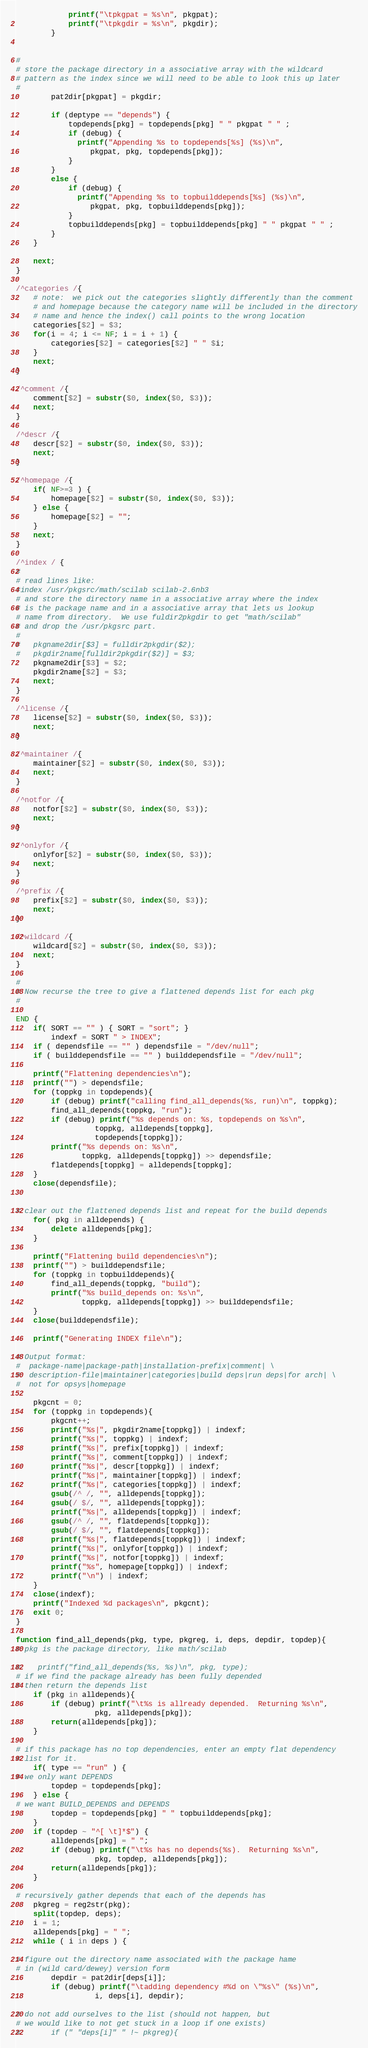<code> <loc_0><loc_0><loc_500><loc_500><_Awk_>			printf("\tpkgpat = %s\n", pkgpat);
			printf("\tpkgdir = %s\n", pkgdir);
		}


#
# store the package directory in a associative array with the wildcard
# pattern as the index since we will need to be able to look this up later
#
		pat2dir[pkgpat] = pkgdir;

		if (deptype == "depends") {
			topdepends[pkg] = topdepends[pkg] " " pkgpat " " ;
			if (debug) {
			  printf("Appending %s to topdepends[%s] (%s)\n",
				 pkgpat, pkg, topdepends[pkg]);
			}
		}
		else {
			if (debug) {
			  printf("Appending %s to topbuilddepends[%s] (%s)\n",
				 pkgpat, pkg, topbuilddepends[pkg]);
			}
			topbuilddepends[pkg] = topbuilddepends[pkg] " " pkgpat " " ;
		}
	}

	next;
}

/^categories /{
	# note:  we pick out the categories slightly differently than the comment
	# and homepage because the category name will be included in the directory
	# name and hence the index() call points to the wrong location
	categories[$2] = $3;
	for(i = 4; i <= NF; i = i + 1) {
		categories[$2] = categories[$2] " " $i;
	}
	next;
}

/^comment /{
	comment[$2] = substr($0, index($0, $3));
	next;
}

/^descr /{
	descr[$2] = substr($0, index($0, $3));
	next;
}

/^homepage /{
	if( NF>=3 ) {
		homepage[$2] = substr($0, index($0, $3));
	} else {
		homepage[$2] = "";
	}
	next;
}

/^index / {
#
# read lines like:
#index /usr/pkgsrc/math/scilab scilab-2.6nb3
# and store the directory name in a associative array where the index
# is the package name and in a associative array that lets us lookup
# name from directory.  We use fuldir2pkgdir to get "math/scilab"
# and drop the /usr/pkgsrc part.
#
#	pkgname2dir[$3] = fulldir2pkgdir($2);
#	pkgdir2name[fulldir2pkgdir($2)] = $3;
	pkgname2dir[$3] = $2;
	pkgdir2name[$2] = $3;
	next;
}

/^license /{
	license[$2] = substr($0, index($0, $3));
	next;
}

/^maintainer /{
	maintainer[$2] = substr($0, index($0, $3));
	next;
}

/^notfor /{
	notfor[$2] = substr($0, index($0, $3));
	next;
}

/^onlyfor /{
	onlyfor[$2] = substr($0, index($0, $3));
	next;
}

/^prefix /{
	prefix[$2] = substr($0, index($0, $3));
	next;
}

/^wildcard /{
	wildcard[$2] = substr($0, index($0, $3));
	next;
}

#
# Now recurse the tree to give a flattened depends list for each pkg
#

END {
	if( SORT == "" ) { SORT = "sort"; }
        indexf = SORT " > INDEX";
	if ( dependsfile == "" ) dependsfile = "/dev/null";
	if ( builddependsfile == "" ) builddependsfile = "/dev/null";

	printf("Flattening dependencies\n");
	printf("") > dependsfile;
	for (toppkg in topdepends){
		if (debug) printf("calling find_all_depends(%s, run)\n", toppkg);
		find_all_depends(toppkg, "run");
		if (debug) printf("%s depends on: %s, topdepends on %s\n",
				  toppkg, alldepends[toppkg],
				  topdepends[toppkg]);
		printf("%s depends on: %s\n",
		       toppkg, alldepends[toppkg]) >> dependsfile;
		flatdepends[toppkg] = alldepends[toppkg];
	}
	close(dependsfile);


# clear out the flattened depends list and repeat for the build depends
	for( pkg in alldepends) {
		delete alldepends[pkg];
	}

	printf("Flattening build dependencies\n");
	printf("") > builddependsfile;
	for (toppkg in topbuilddepends){
		find_all_depends(toppkg, "build");
		printf("%s build_depends on: %s\n",
		       toppkg, alldepends[toppkg]) >> builddependsfile;
	}
	close(builddependsfile);

	printf("Generating INDEX file\n");

# Output format:
#  package-name|package-path|installation-prefix|comment| \
#  description-file|maintainer|categories|build deps|run deps|for arch| \
#  not for opsys|homepage

	pkgcnt = 0;
	for (toppkg in topdepends){
		pkgcnt++;
		printf("%s|", pkgdir2name[toppkg]) | indexf;
		printf("%s|", toppkg) | indexf;
		printf("%s|", prefix[toppkg]) | indexf;
		printf("%s|", comment[toppkg]) | indexf;
		printf("%s|", descr[toppkg]) | indexf;
		printf("%s|", maintainer[toppkg]) | indexf;
		printf("%s|", categories[toppkg]) | indexf;
		gsub(/^ /, "", alldepends[toppkg]);
		gsub(/ $/, "", alldepends[toppkg]);
		printf("%s|", alldepends[toppkg]) | indexf;
		gsub(/^ /, "", flatdepends[toppkg]);
		gsub(/ $/, "", flatdepends[toppkg]);
		printf("%s|", flatdepends[toppkg]) | indexf;
		printf("%s|", onlyfor[toppkg]) | indexf;
		printf("%s|", notfor[toppkg]) | indexf;
		printf("%s", homepage[toppkg]) | indexf;
		printf("\n") | indexf;
	}
	close(indexf);
	printf("Indexed %d packages\n", pkgcnt);
	exit 0;
}

function find_all_depends(pkg, type, pkgreg, i, deps, depdir, topdep){
# pkg is the package directory, like math/scilab

#    printf("find_all_depends(%s, %s)\n", pkg, type);
# if we find the package already has been fully depended
# then return the depends list
	if (pkg in alldepends){
		if (debug) printf("\t%s is allready depended.  Returning %s\n",
				  pkg, alldepends[pkg]);
		return(alldepends[pkg]);
	}

# if this package has no top dependencies, enter an empty flat dependency
# list for it.
	if( type == "run" ) {
# we only want DEPENDS
		topdep = topdepends[pkg];
	} else {
# we want BUILD_DEPENDS and DEPENDS
		topdep = topdepends[pkg] " " topbuilddepends[pkg];
	}
	if (topdep ~ "^[ \t]*$") {
		alldepends[pkg] = " ";
		if (debug) printf("\t%s has no depends(%s).  Returning %s\n",
				  pkg, topdep, alldepends[pkg]);
		return(alldepends[pkg]);
	}

# recursively gather depends that each of the depends has
	pkgreg = reg2str(pkg);
	split(topdep, deps);
	i = 1;
	alldepends[pkg] = " ";
	while ( i in deps ) {

# figure out the directory name associated with the package hame
# in (wild card/dewey) version form
		depdir = pat2dir[deps[i]];
		if (debug) printf("\tadding dependency #%d on \"%s\" (%s)\n",
				  i, deps[i], depdir);

# do not add ourselves to the list (should not happen, but
# we would like to not get stuck in a loop if one exists)
#		if (" "deps[i]" " !~ pkgreg){
</code> 